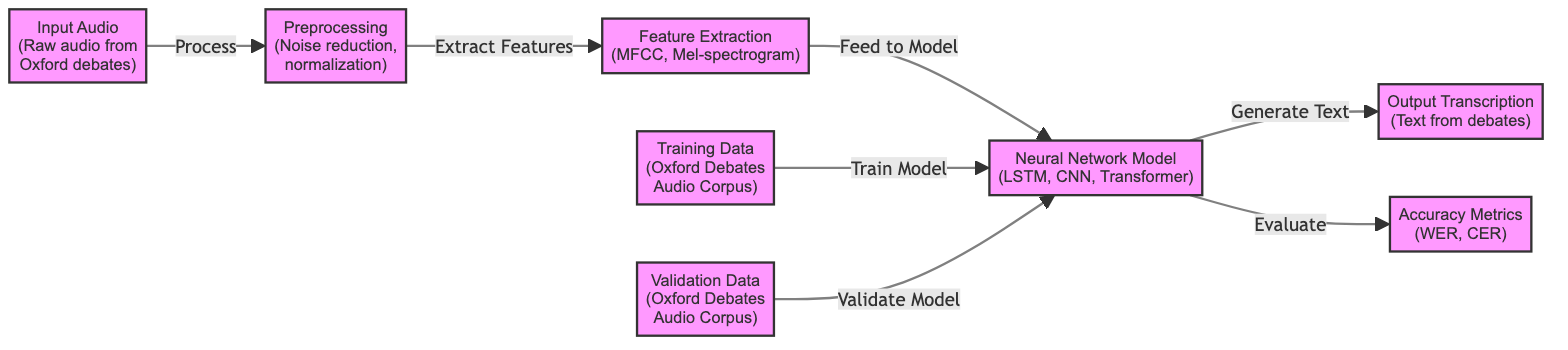What is the first step in the process? The diagram shows that the first step is 'Input Audio', which is raw audio from Oxford debates. This can be seen as the starting node in the flowchart.
Answer: Input Audio How many main nodes are there in the diagram? Counting the nodes in the diagram, there are a total of eight main nodes: Input Audio, Preprocessing, Feature Extraction, Neural Network Model, Training Data, Validation Data, Accuracy Metrics, and Output Transcription.
Answer: Eight What is the output of the neural network model? The diagram indicates that the output of the neural network model is 'Output Transcription', which refers to the text generated from the debates. This is directly connected to the neural network model node.
Answer: Output Transcription What type of data is used for model training? The diagram specifies that 'Training Data' comes from the 'Oxford Debates Audio Corpus', indicating that this specific data source is used to train the model.
Answer: Oxford Debates Audio Corpus Which metrics are associated with evaluating the model? The diagram lists 'WER' and 'CER' as the accuracy metrics used for evaluating the model, indicating that these are the specific measures employed.
Answer: WER, CER How does the feature extraction node relate to preprocessing? The diagram shows an arrow from the 'Preprocessing' node to the 'Feature Extraction' node, indicating that feature extraction is the next step following preprocessing.
Answer: Extract Features What neural network architectures are mentioned in the diagram? The neural network model node specifies three architectures: 'LSTM', 'CNN', and 'Transformer', denoting the types of models utilized in the speech recognition process.
Answer: LSTM, CNN, Transformer What is the purpose of the validation data? The arrow points from 'Validation Data' to the 'Neural Network Model', indicating that the validation data is used to validate the performance of the model after training.
Answer: Validate Model 